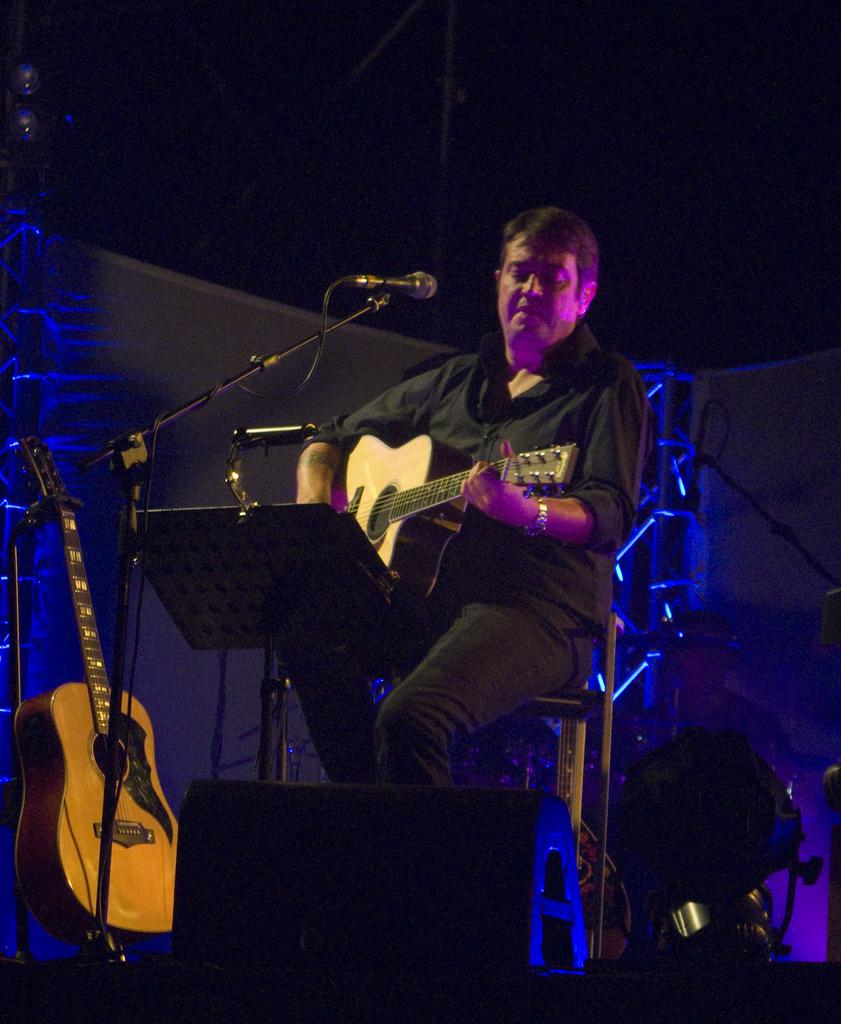What is the main subject of the image? The main subject of the image is a man. What is the man doing in the image? The man is sitting and playing a guitar. Where is the man taking a vacation in the image? There is no indication of a vacation in the image; it simply shows a man sitting and playing a guitar. What type of tub is visible in the image? There is no tub present in the image. 